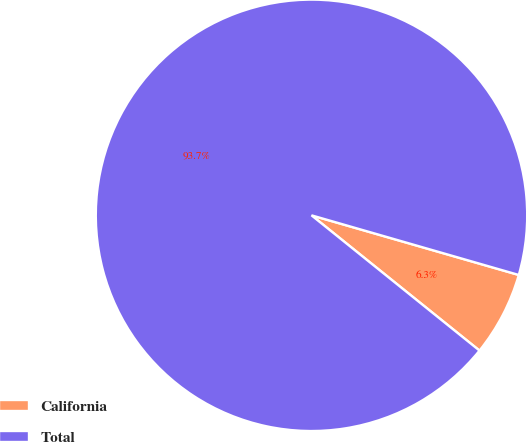Convert chart to OTSL. <chart><loc_0><loc_0><loc_500><loc_500><pie_chart><fcel>California<fcel>Total<nl><fcel>6.33%<fcel>93.67%<nl></chart> 